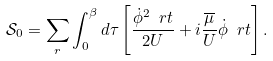Convert formula to latex. <formula><loc_0><loc_0><loc_500><loc_500>\mathcal { S } _ { 0 } = \sum _ { r } \int _ { 0 } ^ { \beta } d \tau \left [ \frac { \dot { \phi } ^ { 2 } \ r t } { 2 U } + i \frac { \overline { \mu } } { U } \dot { \phi } \ r t \right ] .</formula> 